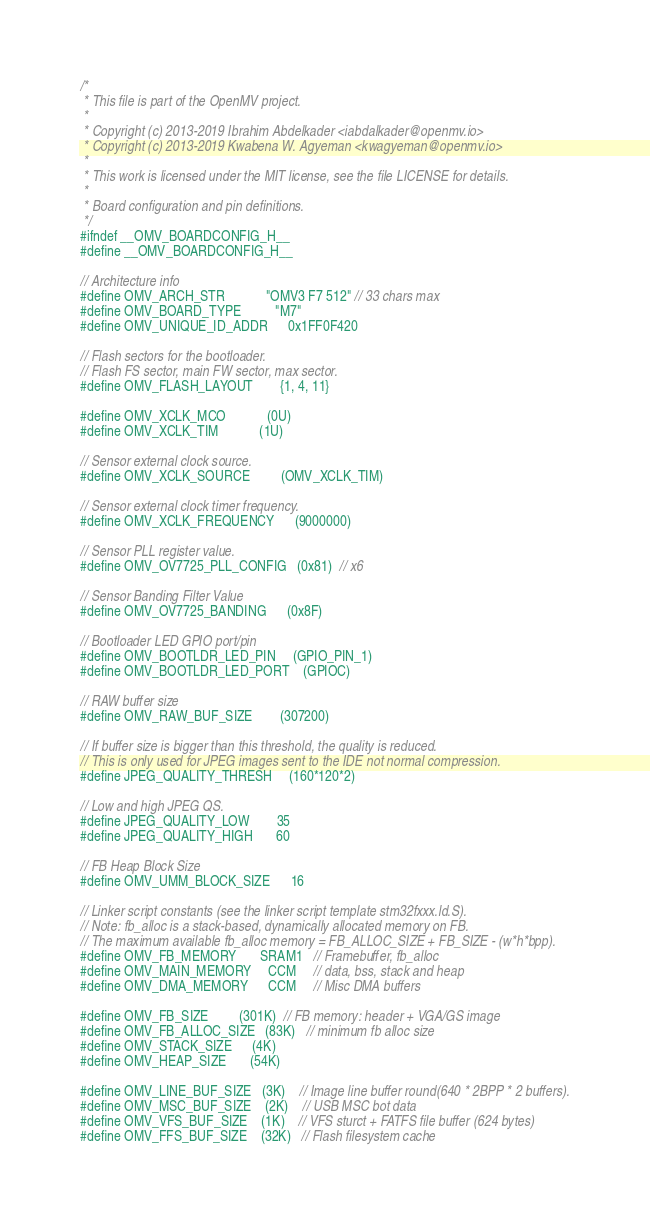<code> <loc_0><loc_0><loc_500><loc_500><_C_>/*
 * This file is part of the OpenMV project.
 *
 * Copyright (c) 2013-2019 Ibrahim Abdelkader <iabdalkader@openmv.io>
 * Copyright (c) 2013-2019 Kwabena W. Agyeman <kwagyeman@openmv.io>
 *
 * This work is licensed under the MIT license, see the file LICENSE for details.
 *
 * Board configuration and pin definitions.
 */
#ifndef __OMV_BOARDCONFIG_H__
#define __OMV_BOARDCONFIG_H__

// Architecture info
#define OMV_ARCH_STR            "OMV3 F7 512" // 33 chars max
#define OMV_BOARD_TYPE          "M7"
#define OMV_UNIQUE_ID_ADDR      0x1FF0F420

// Flash sectors for the bootloader.
// Flash FS sector, main FW sector, max sector.
#define OMV_FLASH_LAYOUT        {1, 4, 11}

#define OMV_XCLK_MCO            (0U)
#define OMV_XCLK_TIM            (1U)

// Sensor external clock source.
#define OMV_XCLK_SOURCE         (OMV_XCLK_TIM)

// Sensor external clock timer frequency.
#define OMV_XCLK_FREQUENCY      (9000000)

// Sensor PLL register value.
#define OMV_OV7725_PLL_CONFIG   (0x81)  // x6

// Sensor Banding Filter Value
#define OMV_OV7725_BANDING      (0x8F)

// Bootloader LED GPIO port/pin
#define OMV_BOOTLDR_LED_PIN     (GPIO_PIN_1)
#define OMV_BOOTLDR_LED_PORT    (GPIOC)

// RAW buffer size
#define OMV_RAW_BUF_SIZE        (307200)

// If buffer size is bigger than this threshold, the quality is reduced.
// This is only used for JPEG images sent to the IDE not normal compression.
#define JPEG_QUALITY_THRESH     (160*120*2)

// Low and high JPEG QS.
#define JPEG_QUALITY_LOW        35
#define JPEG_QUALITY_HIGH       60

// FB Heap Block Size
#define OMV_UMM_BLOCK_SIZE      16

// Linker script constants (see the linker script template stm32fxxx.ld.S).
// Note: fb_alloc is a stack-based, dynamically allocated memory on FB.
// The maximum available fb_alloc memory = FB_ALLOC_SIZE + FB_SIZE - (w*h*bpp).
#define OMV_FB_MEMORY       SRAM1   // Framebuffer, fb_alloc
#define OMV_MAIN_MEMORY     CCM     // data, bss, stack and heap
#define OMV_DMA_MEMORY      CCM     // Misc DMA buffers

#define OMV_FB_SIZE         (301K)  // FB memory: header + VGA/GS image
#define OMV_FB_ALLOC_SIZE   (83K)   // minimum fb alloc size
#define OMV_STACK_SIZE      (4K)
#define OMV_HEAP_SIZE       (54K)

#define OMV_LINE_BUF_SIZE   (3K)    // Image line buffer round(640 * 2BPP * 2 buffers).
#define OMV_MSC_BUF_SIZE    (2K)    // USB MSC bot data
#define OMV_VFS_BUF_SIZE    (1K)    // VFS sturct + FATFS file buffer (624 bytes)
#define OMV_FFS_BUF_SIZE    (32K)   // Flash filesystem cache</code> 